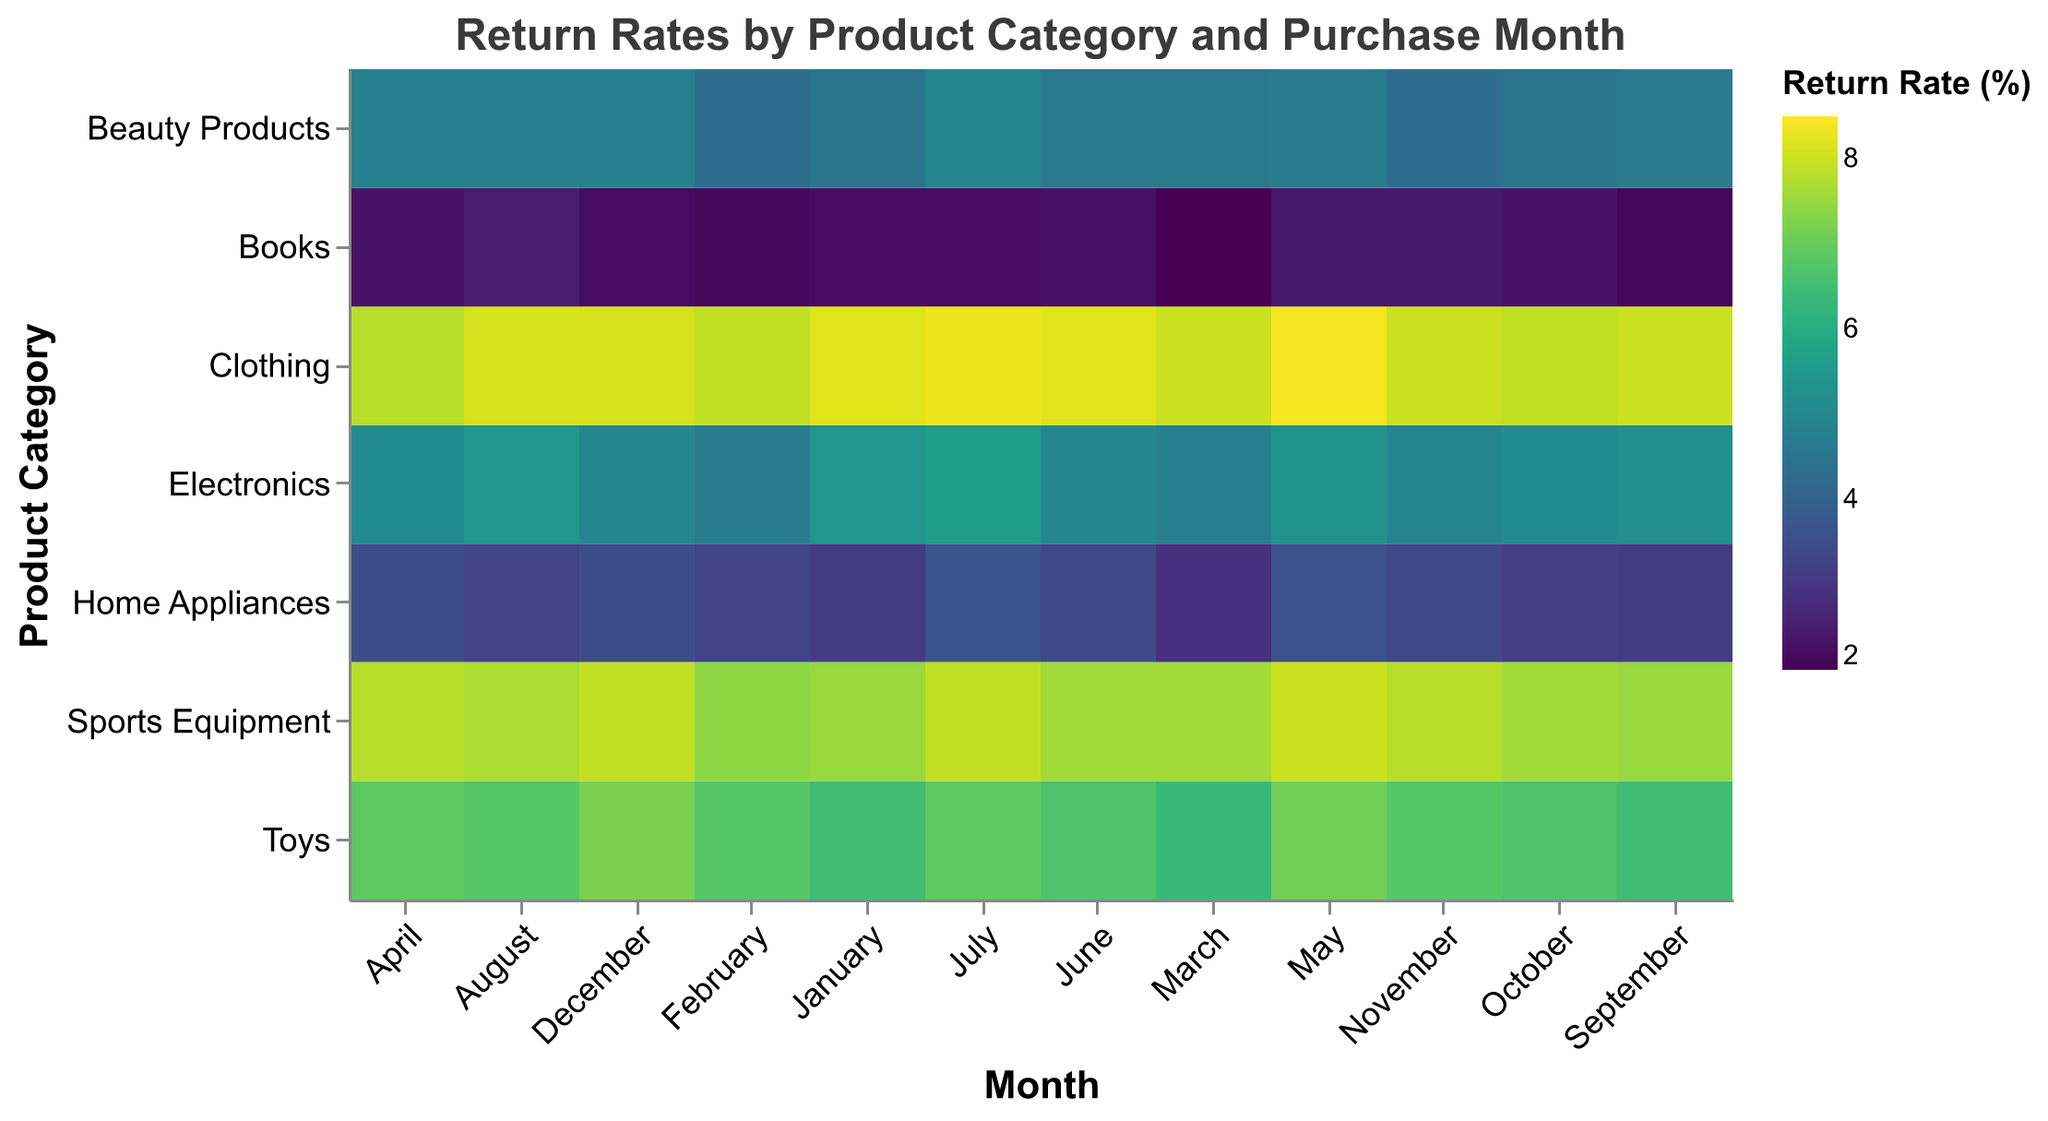What is the return rate for Toys in December? Locate the row for Toys and the column for December, where the value is 7.2.
Answer: 7.2 Which product category has the lowest return rate in February? Compare the return rates for all product categories in February. Books has the lowest value at 2.1.
Answer: Books What is the average return rate for Electronics across all months? Sum the return rates for Electronics (5.4 + 4.7 + 4.8 + 5.1 + 5.3 + 5.0 + 5.6 + 5.4 + 5.2 + 5.1 + 4.9 + 5.0) and divide by 12. The average is (61.5 / 12) = 5.125.
Answer: 5.125 How does the return rate for Home Appliances in July compare to November? Locate the return rates for Home Appliances in July (3.7) and November (3.4). July is higher than November.
Answer: July is higher Which month shows the highest return rate for Clothing? Identify the highest value in the Clothing row. May has the highest value at 8.4.
Answer: May What's the difference in return rates for Books between March and April? Subtract the return rate for Books in March (2.0) from April (2.3). The difference is 2.3 - 2.0 = 0.3.
Answer: 0.3 In which month does Beauty Products have the highest return rate? Identify the highest value in the Beauty Products row. July has the highest value at 4.9.
Answer: July What is the return rate for Sports Equipment in January relative to September? Locate the return rates for Sports Equipment in January (7.5) and September (7.5). The return rate in January is equal to September.
Answer: Equal Which product category generally has the lowest return rates across all months? Compare the overall return rates for all product categories. Books generally has the lowest return rates.
Answer: Books 